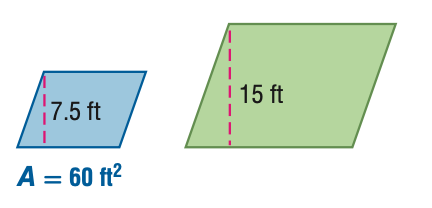Question: For the pair of similar figures, find the area of the green figure.
Choices:
A. 15
B. 30
C. 120
D. 240
Answer with the letter. Answer: D 